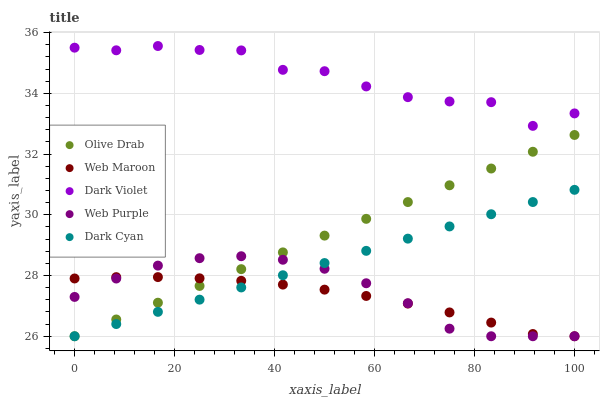Does Web Maroon have the minimum area under the curve?
Answer yes or no. Yes. Does Dark Violet have the maximum area under the curve?
Answer yes or no. Yes. Does Web Purple have the minimum area under the curve?
Answer yes or no. No. Does Web Purple have the maximum area under the curve?
Answer yes or no. No. Is Dark Cyan the smoothest?
Answer yes or no. Yes. Is Dark Violet the roughest?
Answer yes or no. Yes. Is Web Purple the smoothest?
Answer yes or no. No. Is Web Purple the roughest?
Answer yes or no. No. Does Dark Cyan have the lowest value?
Answer yes or no. Yes. Does Dark Violet have the lowest value?
Answer yes or no. No. Does Dark Violet have the highest value?
Answer yes or no. Yes. Does Web Purple have the highest value?
Answer yes or no. No. Is Web Maroon less than Dark Violet?
Answer yes or no. Yes. Is Dark Violet greater than Dark Cyan?
Answer yes or no. Yes. Does Olive Drab intersect Web Purple?
Answer yes or no. Yes. Is Olive Drab less than Web Purple?
Answer yes or no. No. Is Olive Drab greater than Web Purple?
Answer yes or no. No. Does Web Maroon intersect Dark Violet?
Answer yes or no. No. 